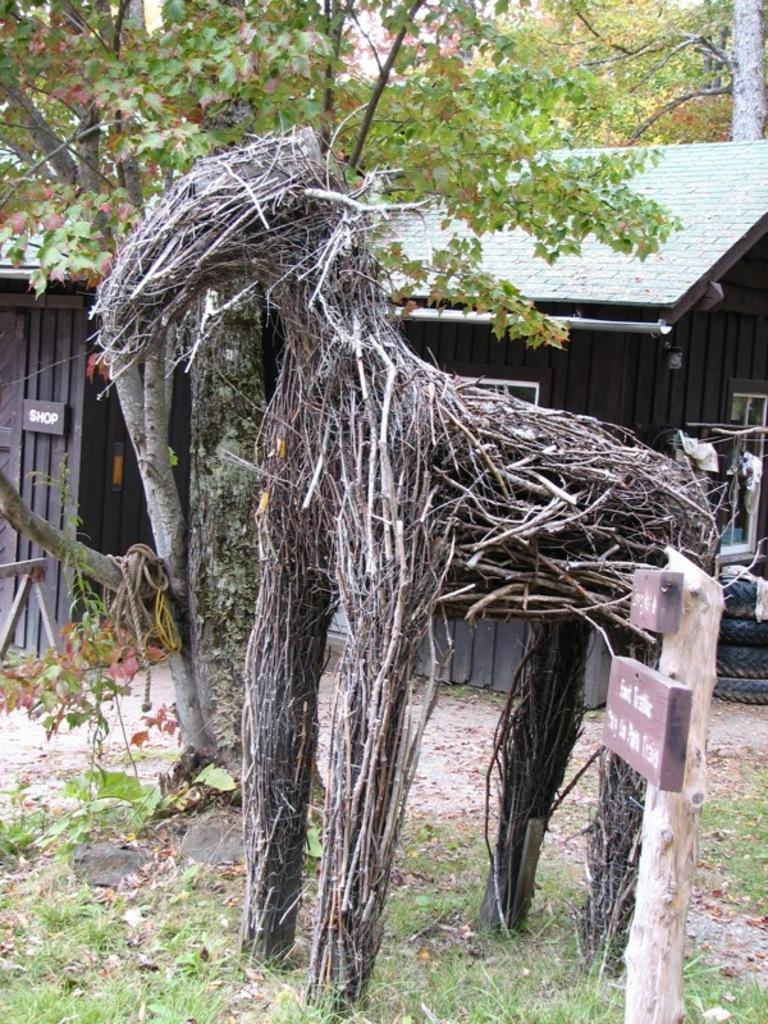What type of object is the main subject of the image? There is a wooden model of an animal in the image. What can be seen in the foreground of the image? There is a pole in the foreground of the image. What is visible in the background of the image? There are trees and a house in the background of the image. What type of plastic object is visible in the image? There is no plastic object present in the image. Can you see a rabbit playing near the wooden model in the image? There is no rabbit present in the image; it only features a wooden model of an animal. Is there a church visible in the background of the image? There is no church mentioned in the provided facts, only a house is mentioned in the background. 